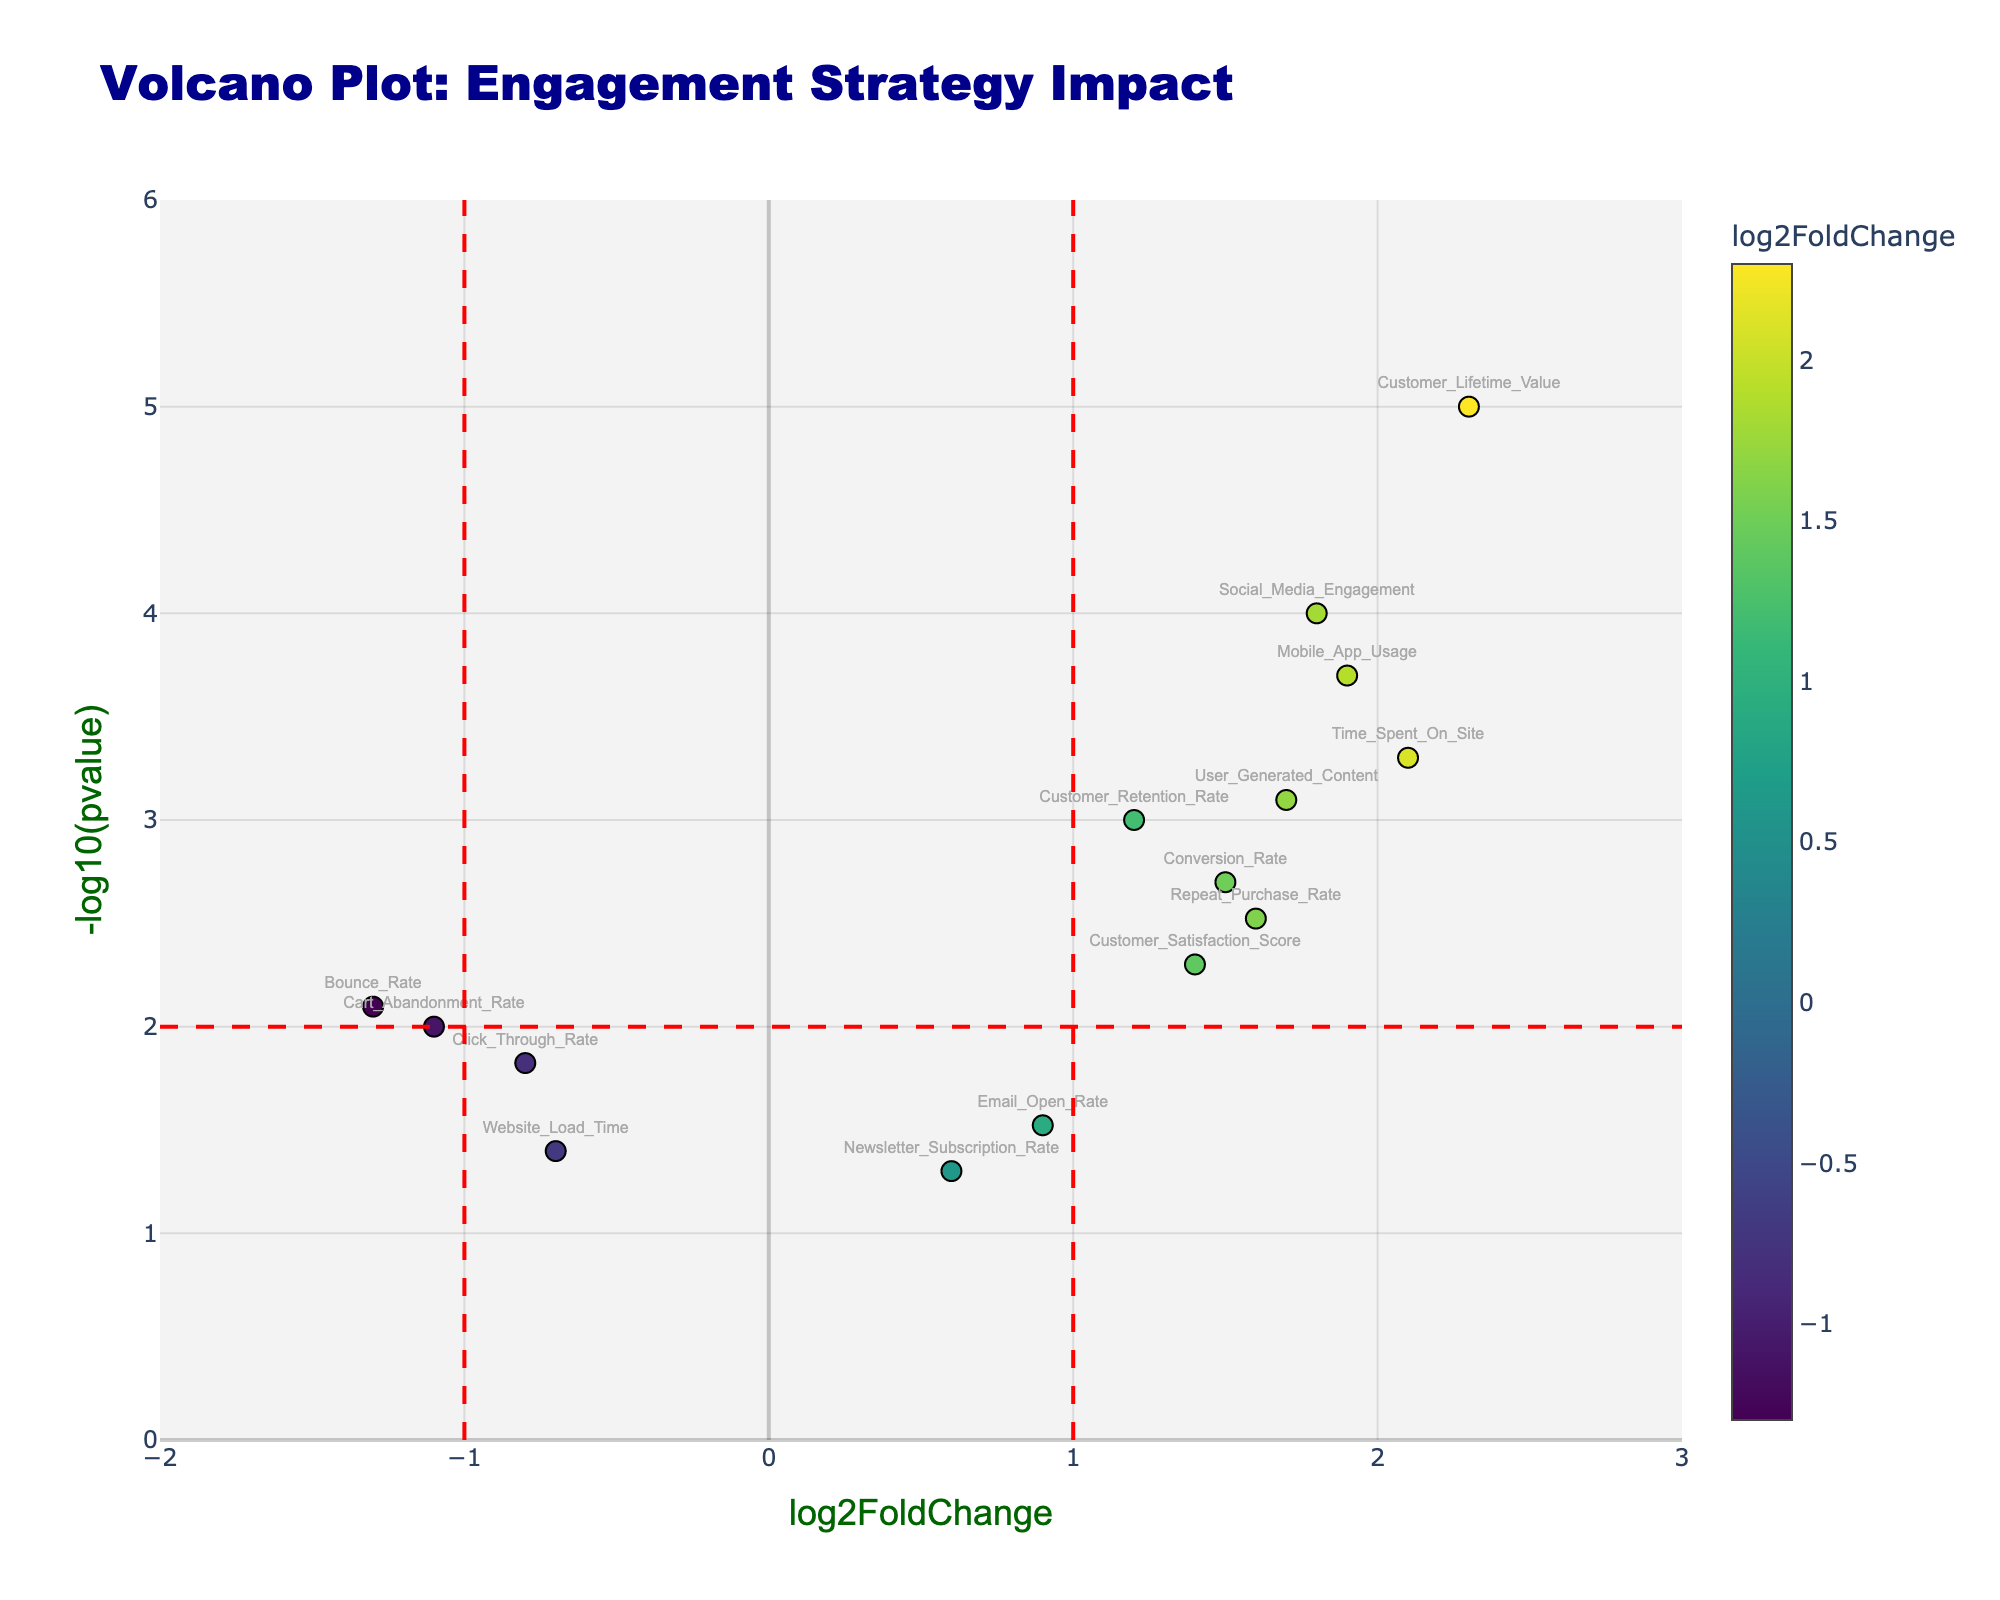What does the title of the plot indicate? The title of the plot, "Volcano Plot: Engagement Strategy Impact," suggests that the plot is used to visualize the impact of a new engagement strategy through differential protein abundance metrics, represented as log2 fold changes and p-values.
Answer: Engagement Strategy Impact Which metric has the highest differential abundance with a very low p-value? By looking at the point at the highest value on the y-axis and the farthest right on the x-axis, "Customer_Lifetime_Value" is identified, having a high log2FoldChange (2.3) with a very low p-value (significantly below the x-axis threshold lines).
Answer: Customer_Lifetime_Value How many metrics have a log2FoldChange of less than -1? The points to the left of the vertical red dashed line at x = -1 signify metrics with log2FoldChange less than -1. There are three such points: "Click_Through_Rate," "Bounce_Rate," and "Cart_Abandonment_Rate."
Answer: 3 Are there any metrics whose differential abundance is not statistically significant? Points with a -log10(pvalue) below 2 can be considered not statistically significant. By visual inspection, "Email_Open_Rate" and "Website_Load_Time" fall below this line, indicating their non-significance.
Answer: Yes How does Social_Media_Engagement compare to Bounce_Rate regarding their log2FoldChange values? Comparing the positions on the x-axis, "Social_Media_Engagement" has a log2FoldChange of 1.8, significantly higher than "Bounce_Rate" which is at -1.3.
Answer: Social_Media_Engagement has a higher log2FoldChange Which metric showed the greatest improvement after implementing the strategy? The metric at the highest positive log2FoldChange value represents the greatest improvement, which is "Customer_Lifetime_Value" at 2.3.
Answer: Customer_Lifetime_Value How many metrics have a positive log2FoldChange and are statistically significant (p-value < 0.05)? Metrics to the right of the x = 0 line with -log10(pvalue) above 1.3 (threshold for p-value < 0.05) are positive and significant. There are nine such points: "Customer_Retention_Rate," "Time_Spent_On_Site," "Conversion_Rate," "Social_Media_Engagement," "Customer_Lifetime_Value," "Repeat_Purchase_Rate," "Customer_Satisfaction_Score," "Mobile_App_Usage," and "User_Generated_Content."
Answer: 9 What can you say about the differential abundance of Time_Spent_On_Site? By observing its position, "Time_Spent_On_Site" is right of the x = 2 line and above the y = 2 line, indicating a high log2FoldChange of 2.1 with a statistically significant p-value (below 0.0005).
Answer: High log2FoldChange, significant Which metrics decreased in abundance post-strategy implementation? Metrics left of the x = 0 line experienced a decline. "Click_Through_Rate," "Bounce_Rate," "Cart_Abandonment_Rate," and "Website_Load_Time" fall in this region.
Answer: Click_Through_Rate, Bounce_Rate, Cart_Abandonment_Rate, Website_Load_Time 